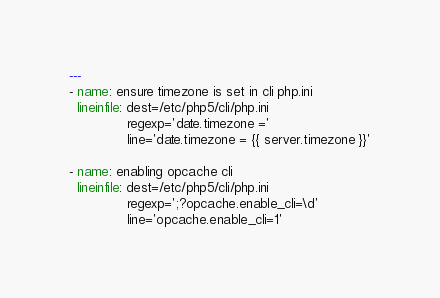<code> <loc_0><loc_0><loc_500><loc_500><_YAML_>---
- name: ensure timezone is set in cli php.ini
  lineinfile: dest=/etc/php5/cli/php.ini
              regexp='date.timezone ='
              line='date.timezone = {{ server.timezone }}'

- name: enabling opcache cli
  lineinfile: dest=/etc/php5/cli/php.ini
              regexp=';?opcache.enable_cli=\d'
              line='opcache.enable_cli=1'</code> 